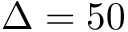<formula> <loc_0><loc_0><loc_500><loc_500>\Delta = 5 0</formula> 